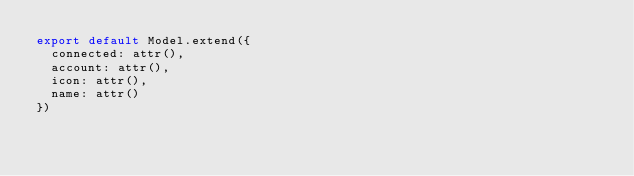<code> <loc_0><loc_0><loc_500><loc_500><_JavaScript_>export default Model.extend({
  connected: attr(),
  account: attr(),
  icon: attr(),
  name: attr()
})
</code> 